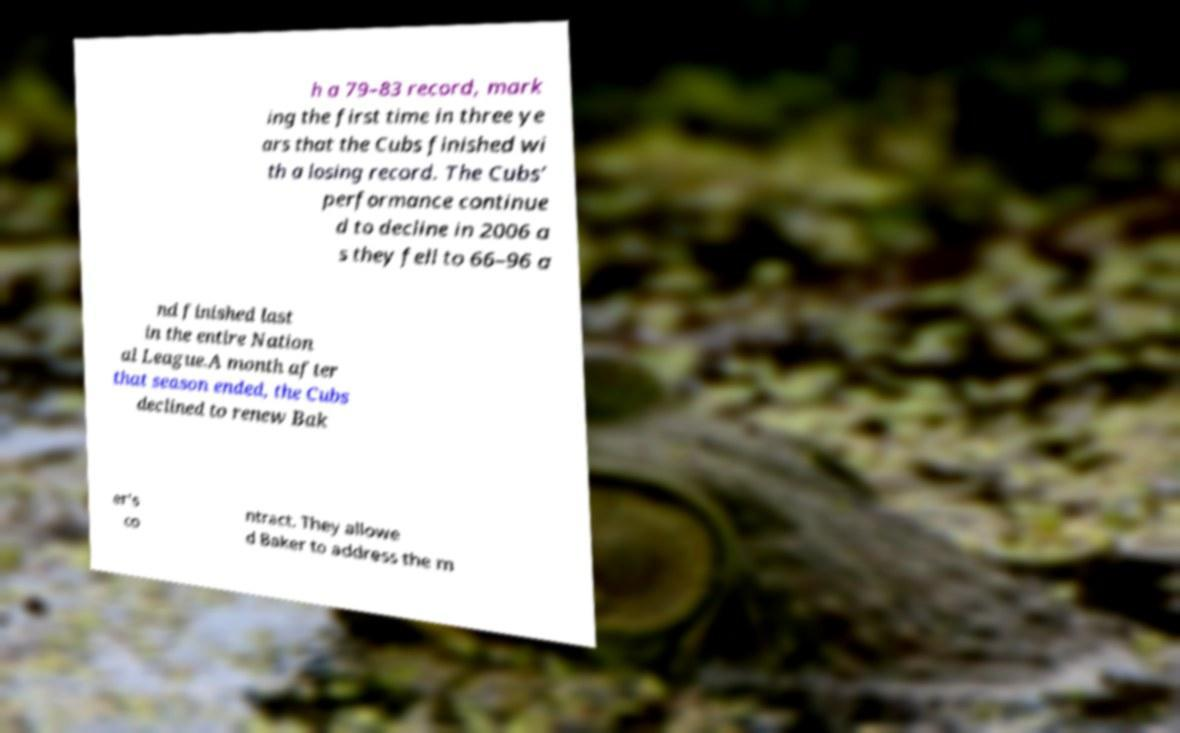Could you assist in decoding the text presented in this image and type it out clearly? h a 79–83 record, mark ing the first time in three ye ars that the Cubs finished wi th a losing record. The Cubs’ performance continue d to decline in 2006 a s they fell to 66–96 a nd finished last in the entire Nation al League.A month after that season ended, the Cubs declined to renew Bak er's co ntract. They allowe d Baker to address the m 